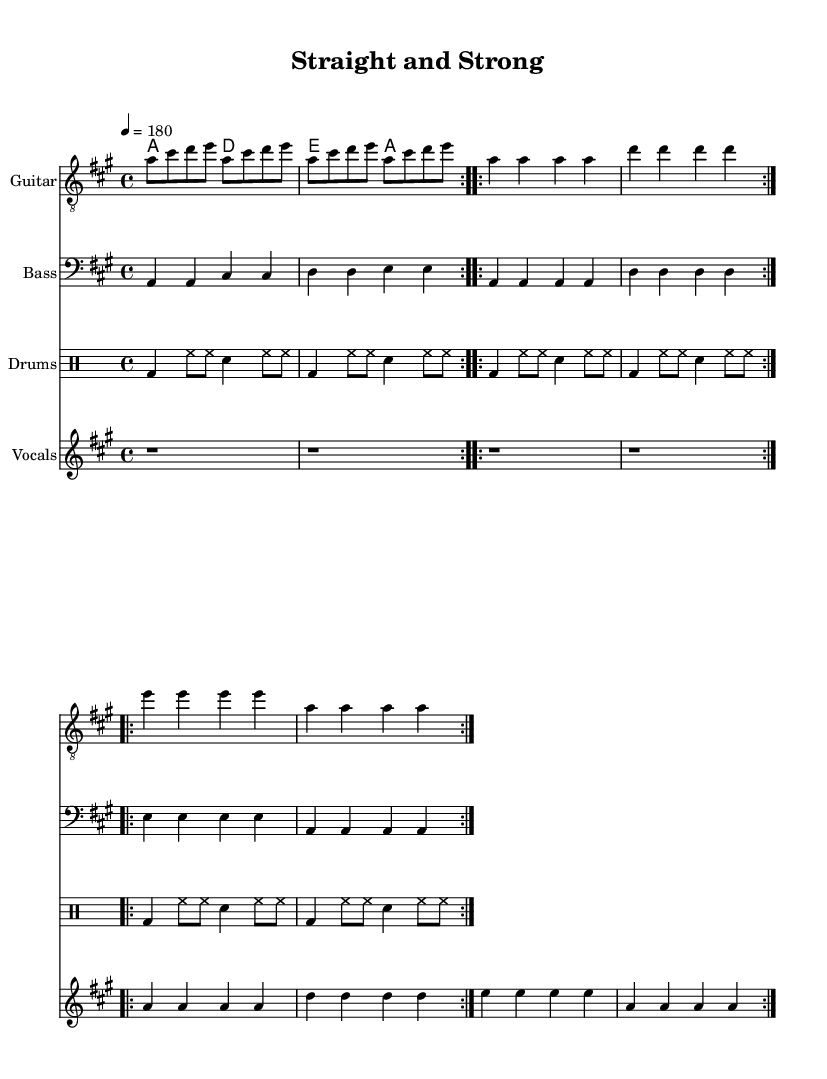What is the title of this piece? The title is indicated in the header section of the sheet music. It states "Straight and Strong."
Answer: Straight and Strong What is the time signature of this music? The time signature is found at the beginning of the score. It shows 4/4, meaning there are four beats per measure, and the quarter note gets one beat.
Answer: 4/4 What is the tempo marking for this piece? The tempo marking is specified under the global context and indicates the speed of the piece. It reads “4 = 180,” which means 180 beats per minute.
Answer: 180 What are the main themes expressed in the lyrics? Analyzing the lyrics, they emphasize a clean and strong lifestyle, specifically mentioning being drug-free and promoting positive choices. The repeated themes suggest resilience against negative influences.
Answer: Drug-free life How many times is the guitar riff repeated? Looking at the guitar part, the riff is repeated twice before moving on to the next section, as indicated by the "repeat volta" notation.
Answer: 2 times Which chord progression is used during the chorus? The chord progression is present in the chord mode section indicating the chords played during the chorus. The chords are A, D, and E in succession.
Answer: A, D, E What is the primary message of the song? By combining the lyrics and thematic context, it conveys a straightforward message against drug use and promotes strength and unity among listeners who share this lifestyle.
Answer: Strong and united 